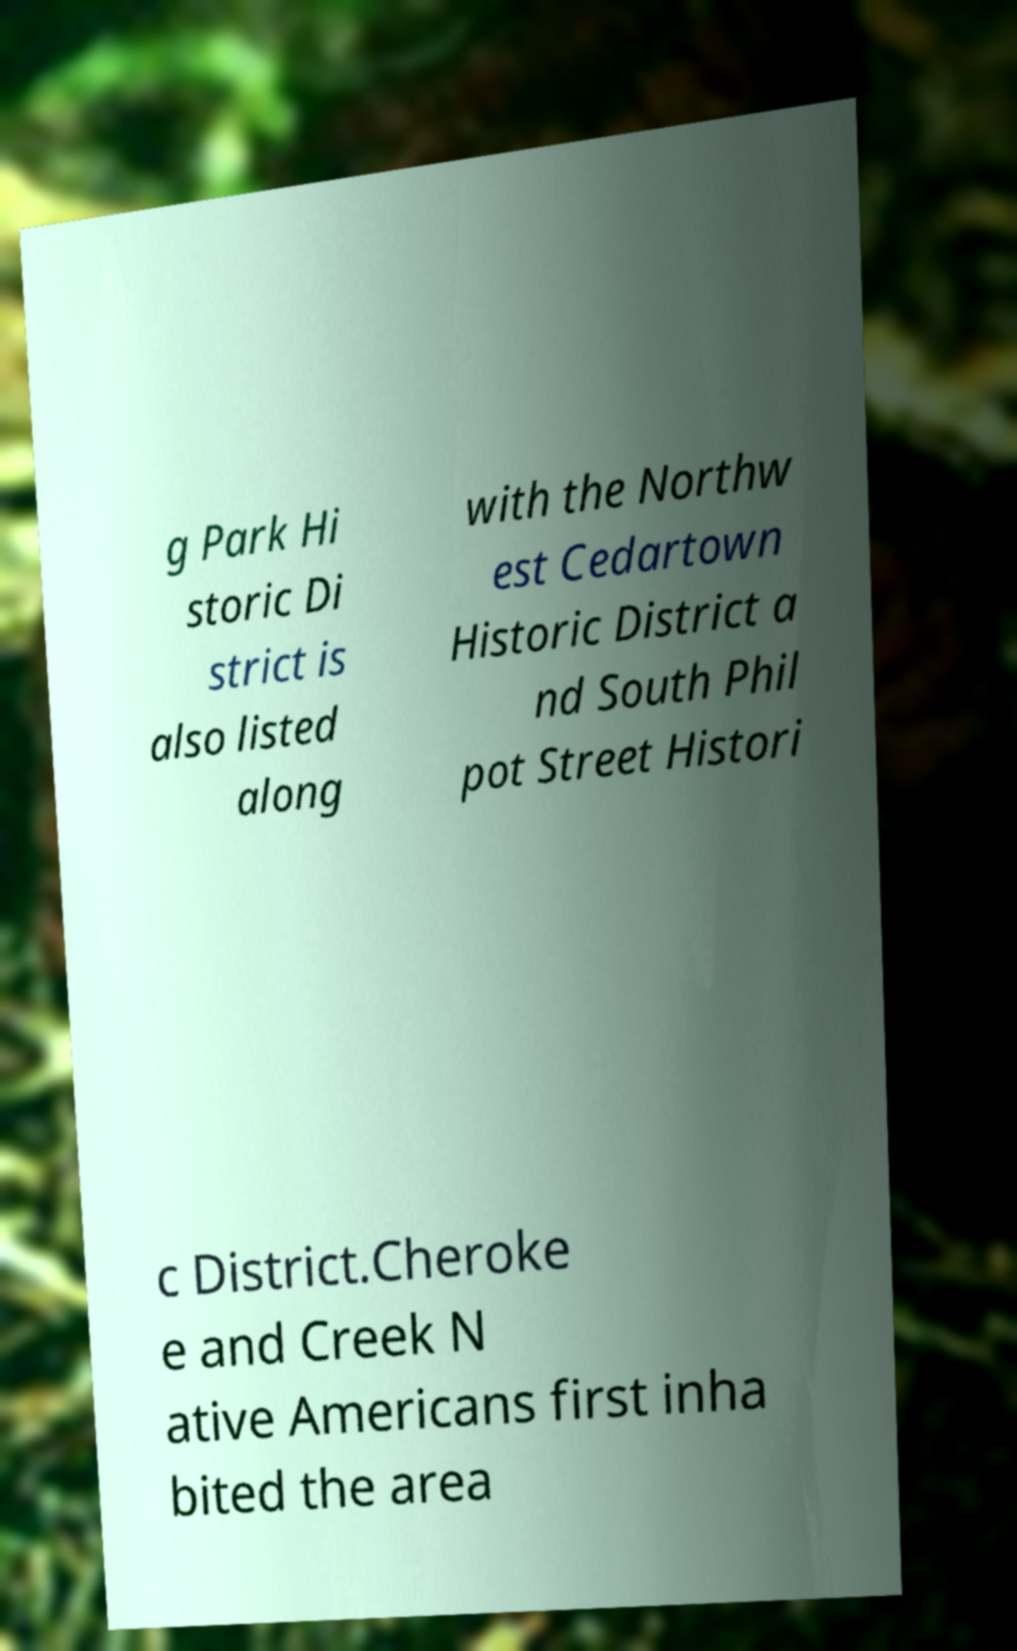Could you extract and type out the text from this image? g Park Hi storic Di strict is also listed along with the Northw est Cedartown Historic District a nd South Phil pot Street Histori c District.Cheroke e and Creek N ative Americans first inha bited the area 